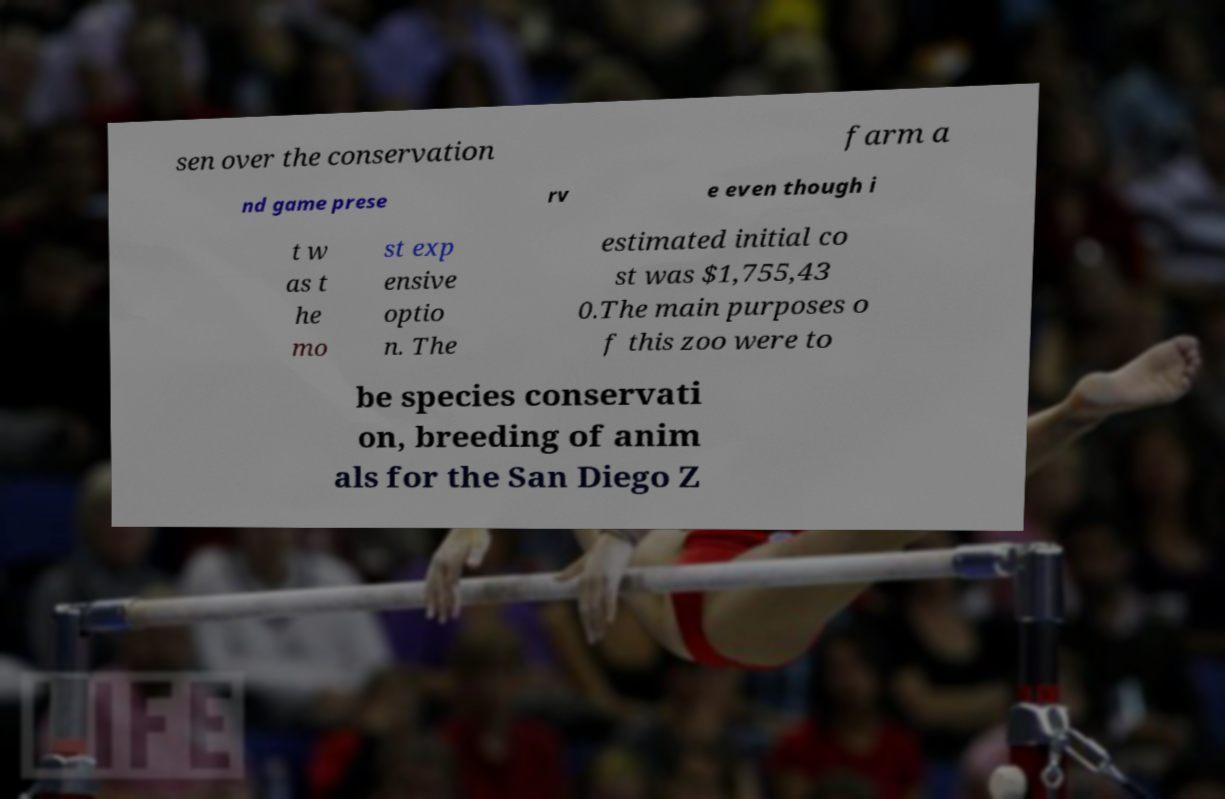There's text embedded in this image that I need extracted. Can you transcribe it verbatim? sen over the conservation farm a nd game prese rv e even though i t w as t he mo st exp ensive optio n. The estimated initial co st was $1,755,43 0.The main purposes o f this zoo were to be species conservati on, breeding of anim als for the San Diego Z 